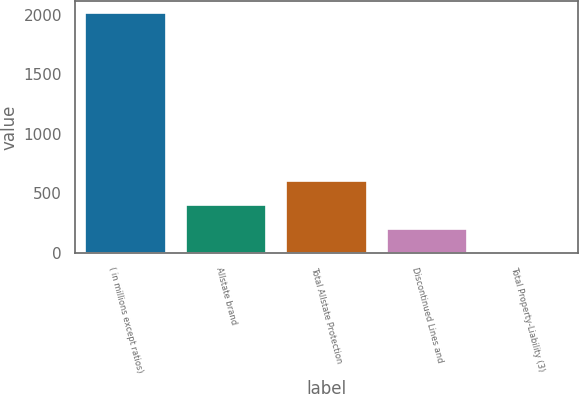<chart> <loc_0><loc_0><loc_500><loc_500><bar_chart><fcel>( in millions except ratios)<fcel>Allstate brand<fcel>Total Allstate Protection<fcel>Discontinued Lines and<fcel>Total Property-Liability (3)<nl><fcel>2013<fcel>402.92<fcel>604.18<fcel>201.66<fcel>0.4<nl></chart> 